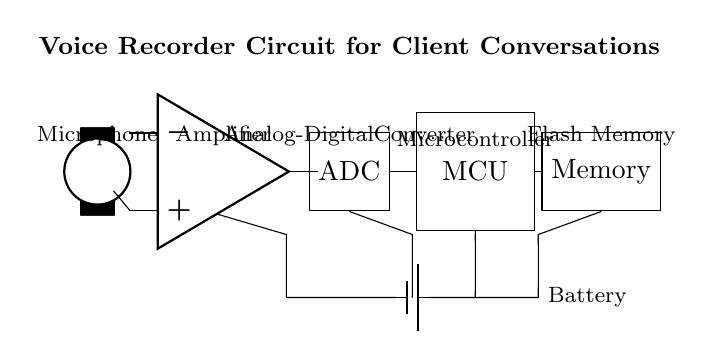What is the primary function of the microphone in this circuit? The microphone's primary function is to convert sound waves from client conversations into electrical signals. This is the first component in the circuit, indicating its role in capturing audio input.
Answer: Convert sound What type of device is represented by the component labeled ADC? The component labeled ADC stands for Analog-Digital Converter, which is responsible for converting the analog signals from the amplifier into digital signals suitable for processing. This function is fundamental for digital audio recording.
Answer: Analog-Digital Converter How many main components are used in this circuit diagram? The total number of main components is counted by identifying each distinct element: the microphone, amplifier, ADC, microcontroller, memory, and battery. There are six main components shown in the circuit.
Answer: Six Which component in the circuit is responsible for storing recorded audio? The component responsible for storing recorded audio is labeled as Memory, specifically referring to Flash Memory, which retains the digital audio data captured by the microcontroller.
Answer: Memory What is the role of the microcontroller in this circuit? The microcontroller processes the digital signals received from the ADC and manages the operation of the overall system, including controlling the memory for audio storage. This central role is crucial for making the device functional as a voice recorder.
Answer: Control and processing What is the purpose of the battery in this circuit? The battery serves to provide the necessary power supply to all components in the circuit, enabling their operation. It is essential for portable devices like a voice recorder, which need independent power sources.
Answer: Power supply How does sound reach the audio storage in this circuit? Sound waves are first captured by the microphone, converted into electrical signals by the amplifier, transformed into digital signals by the ADC, processed by the microcontroller, and finally stored in the memory component. This sequential flow illustrates the process from audio input to digital storage.
Answer: Through microphone, amplifier, ADC, MCU, to memory 